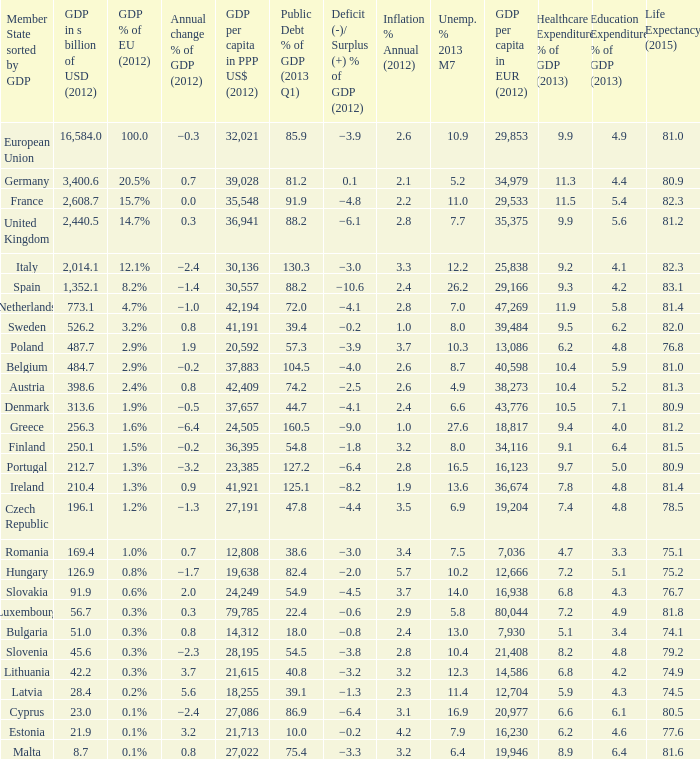What is the deficit/surplus % of the 2012 GDP of the country with a GDP in billions of USD in 2012 less than 1,352.1, a GDP per capita in PPP US dollars in 2012 greater than 21,615, public debt % of GDP in the 2013 Q1 less than 75.4, and an inflation % annual in 2012 of 2.9? −0.6. 